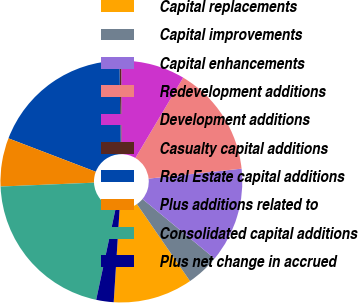<chart> <loc_0><loc_0><loc_500><loc_500><pie_chart><fcel>Capital replacements<fcel>Capital improvements<fcel>Capital enhancements<fcel>Redevelopment additions<fcel>Development additions<fcel>Casualty capital additions<fcel>Real Estate capital additions<fcel>Plus additions related to<fcel>Consolidated capital additions<fcel>Plus net change in accrued<nl><fcel>10.62%<fcel>4.4%<fcel>12.69%<fcel>14.76%<fcel>8.54%<fcel>0.25%<fcel>18.93%<fcel>6.47%<fcel>21.0%<fcel>2.33%<nl></chart> 